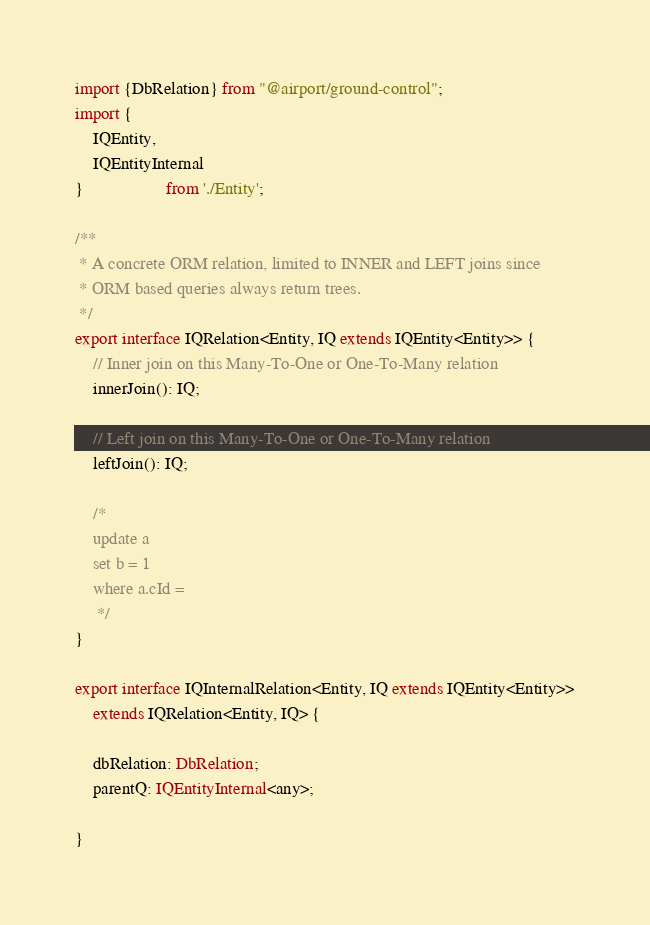Convert code to text. <code><loc_0><loc_0><loc_500><loc_500><_TypeScript_>import {DbRelation} from "@airport/ground-control";
import {
	IQEntity,
	IQEntityInternal
}                   from './Entity';

/**
 * A concrete ORM relation, limited to INNER and LEFT joins since
 * ORM based queries always return trees.
 */
export interface IQRelation<Entity, IQ extends IQEntity<Entity>> {
	// Inner join on this Many-To-One or One-To-Many relation
	innerJoin(): IQ;

	// Left join on this Many-To-One or One-To-Many relation
	leftJoin(): IQ;

	/*
	update a
	set b = 1
	where a.cId =
	 */
}

export interface IQInternalRelation<Entity, IQ extends IQEntity<Entity>>
	extends IQRelation<Entity, IQ> {

	dbRelation: DbRelation;
	parentQ: IQEntityInternal<any>;

}

</code> 